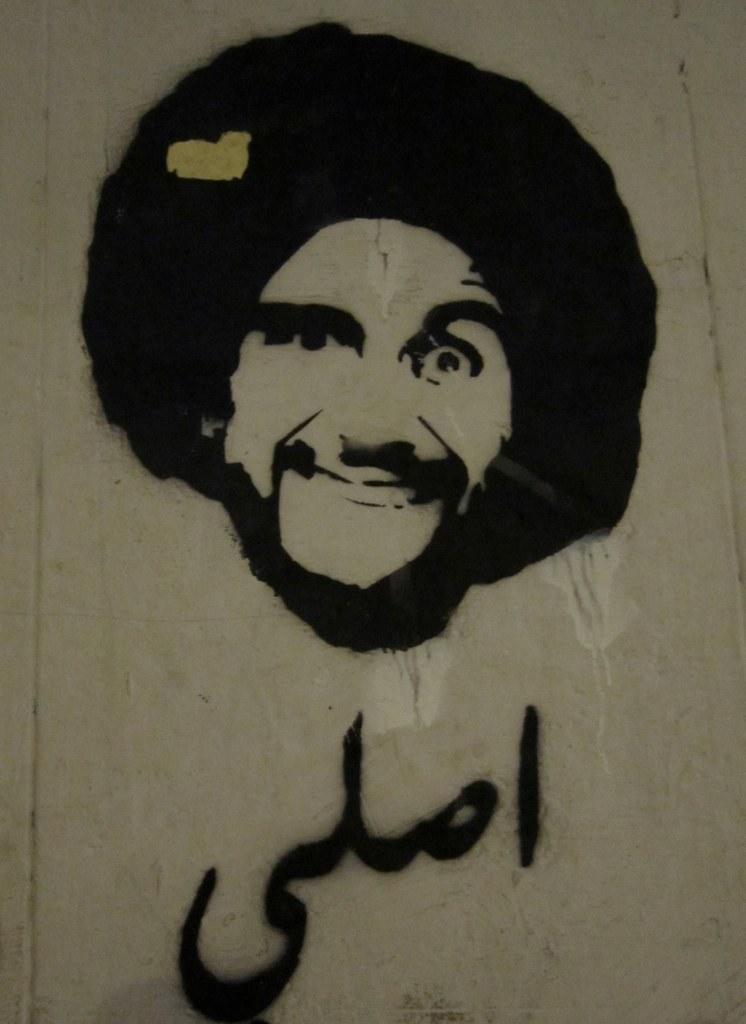Describe this image in one or two sentences. In this picture I can see a painting of a person on the wall. 